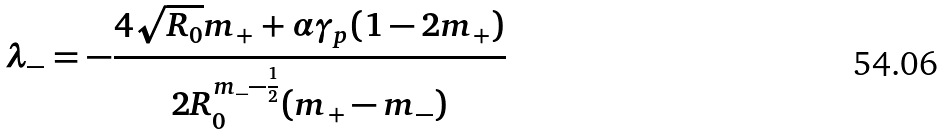<formula> <loc_0><loc_0><loc_500><loc_500>\lambda _ { - } = - \frac { 4 \sqrt { R _ { 0 } } m _ { + } + \alpha \gamma _ { p } ( 1 - 2 m _ { + } ) } { 2 R _ { 0 } ^ { m _ { - } - \frac { 1 } { 2 } } ( m _ { + } - m _ { - } ) }</formula> 